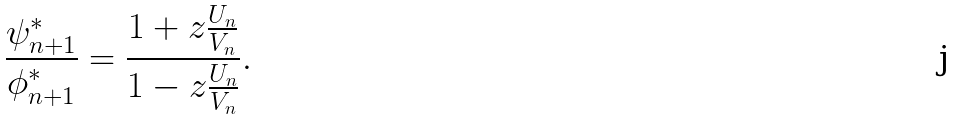Convert formula to latex. <formula><loc_0><loc_0><loc_500><loc_500>\frac { \psi _ { n + 1 } ^ { * } } { \phi _ { n + 1 } ^ { * } } = \frac { 1 + z \frac { U _ { n } } { V _ { n } } } { 1 - z \frac { U _ { n } } { V _ { n } } } .</formula> 